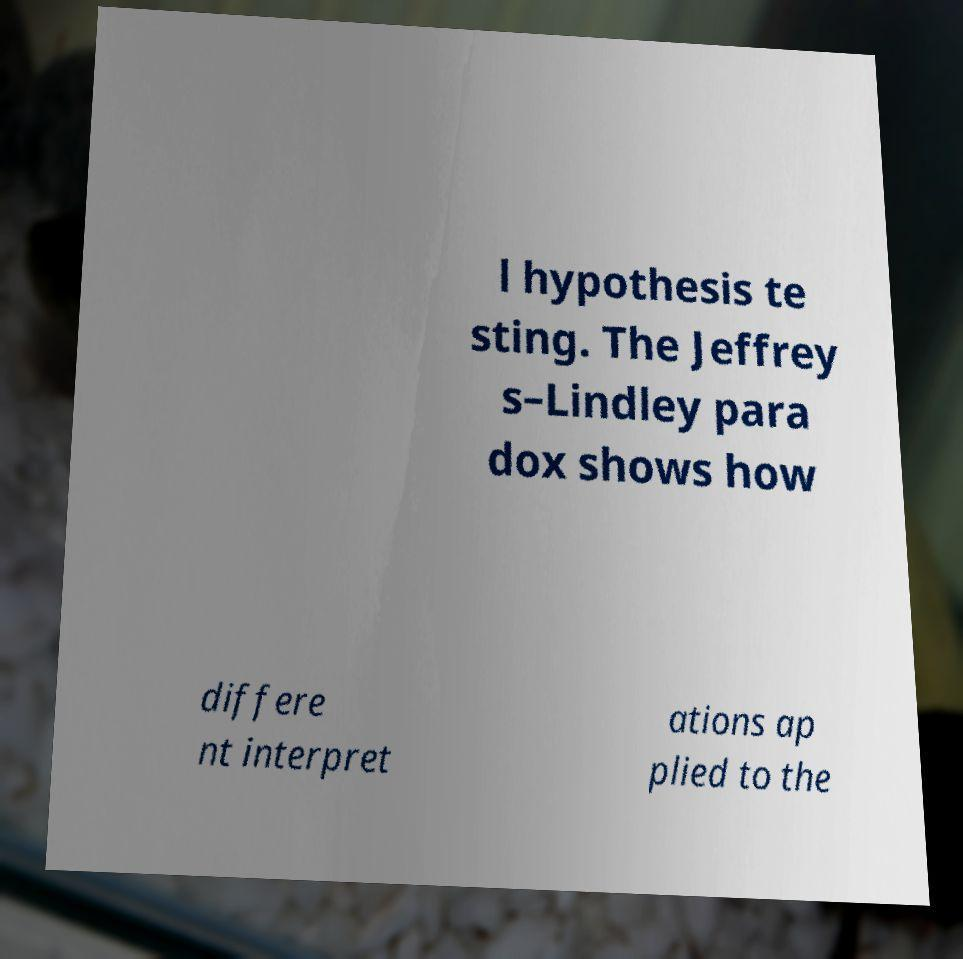For documentation purposes, I need the text within this image transcribed. Could you provide that? l hypothesis te sting. The Jeffrey s–Lindley para dox shows how differe nt interpret ations ap plied to the 